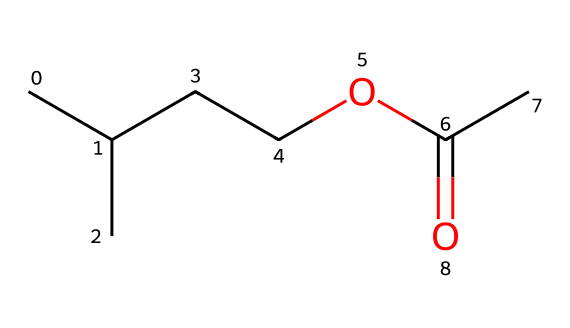What is the molecular formula of isoamyl acetate? To determine the molecular formula, we analyze the structure represented by the SMILES. The carbon (C) count is five from the isopentyl group and one from the acetate group (total six). The hydrogen (H) count totals twelve after considering the saturation. There is also one oxygen (O) from the ester functional group. Thus, the molecular formula is C6H12O2.
Answer: C6H12O2 How many carbon atoms are in isoamyl acetate? By examining the SMILES representation, we count the number of carbon atoms represented. The structure has six carbon atoms (five from the isopentyl part and one from the acetate part).
Answer: 6 What type of functional group does isoamyl acetate belong to? The presence of the ester bond (C(=O)O) in the structure designates this chemical as an ester. This functional group is characterized by a carbonyl (C=O) bonded to an oxy group (O) followed by another hydrocarbon chain.
Answer: ester What is the degree of unsaturation in isoamyl acetate? The degree of unsaturation indicates how many double bonds or rings are in a molecule. For isoamyl acetate, there is one double bond in the carbonyl group and no rings. Hence, the degree of unsaturation is calculated as 1 (from C=O).
Answer: 1 What role does isoamyl acetate play in food development? Isoamyl acetate is commonly used as a flavoring agent, providing a banana-like aroma. Its chemical structure contributes to its sweet and fruity fragrance, making it valuable in food products, especially in artificial flavorings.
Answer: flavoring agent Does isoamyl acetate have any associated health risks? While isoamyl acetate is generally recognized as safe in food applications, excessive inhalation or ingestion may pose health risks such as irritation. Nonetheless, when used correctly within regulatory limits, it is safe for consumption.
Answer: mild irritation risk 